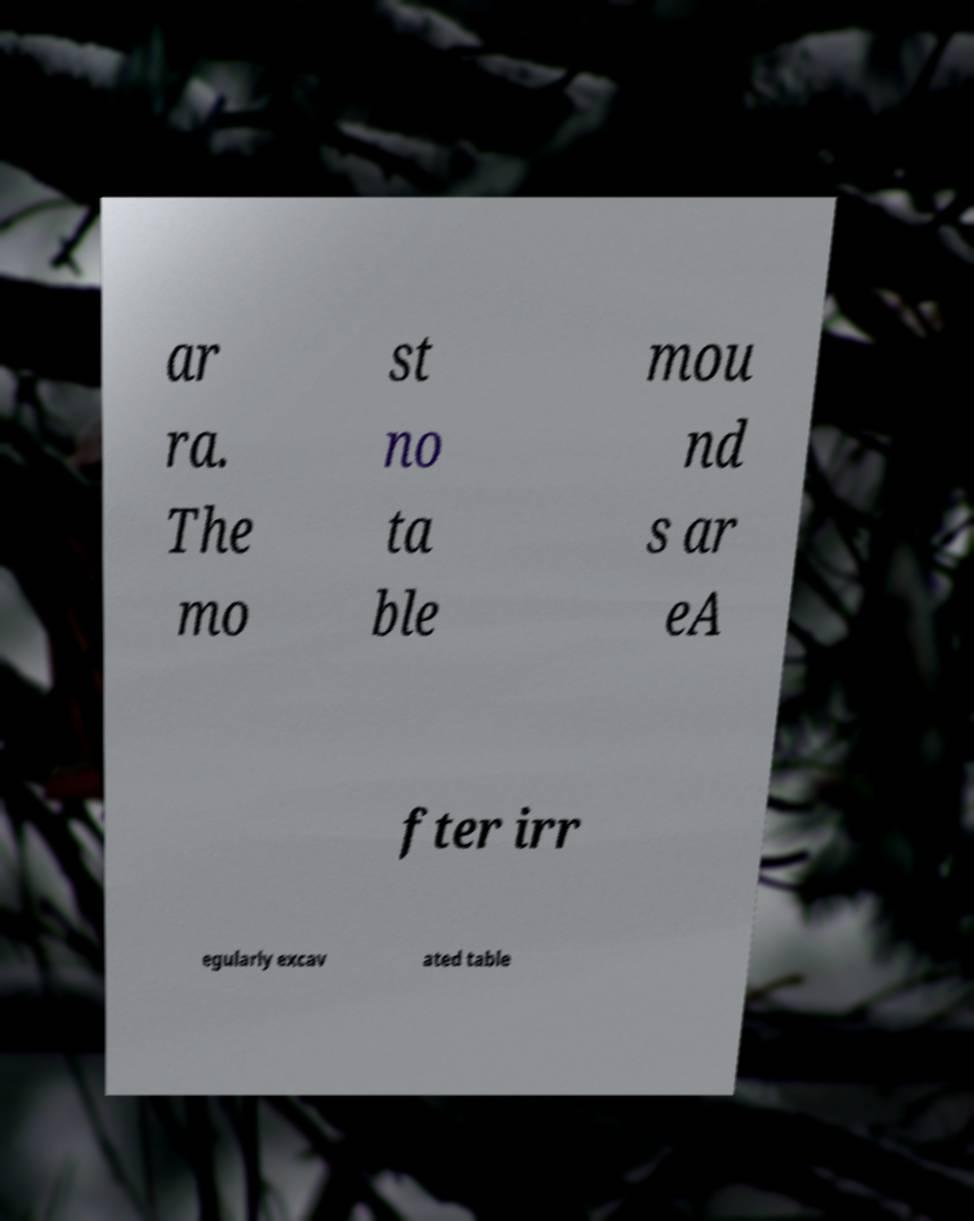For documentation purposes, I need the text within this image transcribed. Could you provide that? ar ra. The mo st no ta ble mou nd s ar eA fter irr egularly excav ated table 